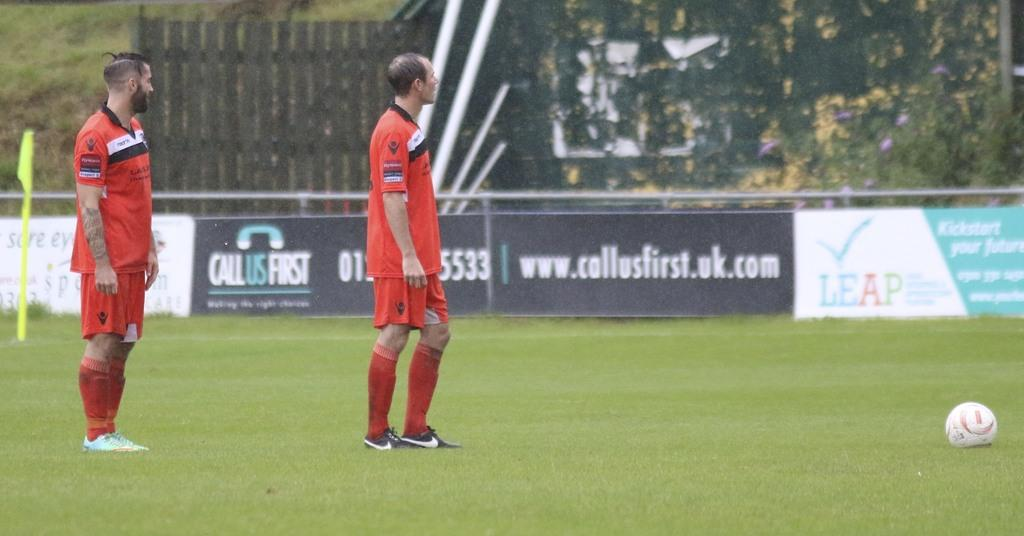Provide a one-sentence caption for the provided image. Two soccer players standing next to a ball with an ad for call us first in the background. 